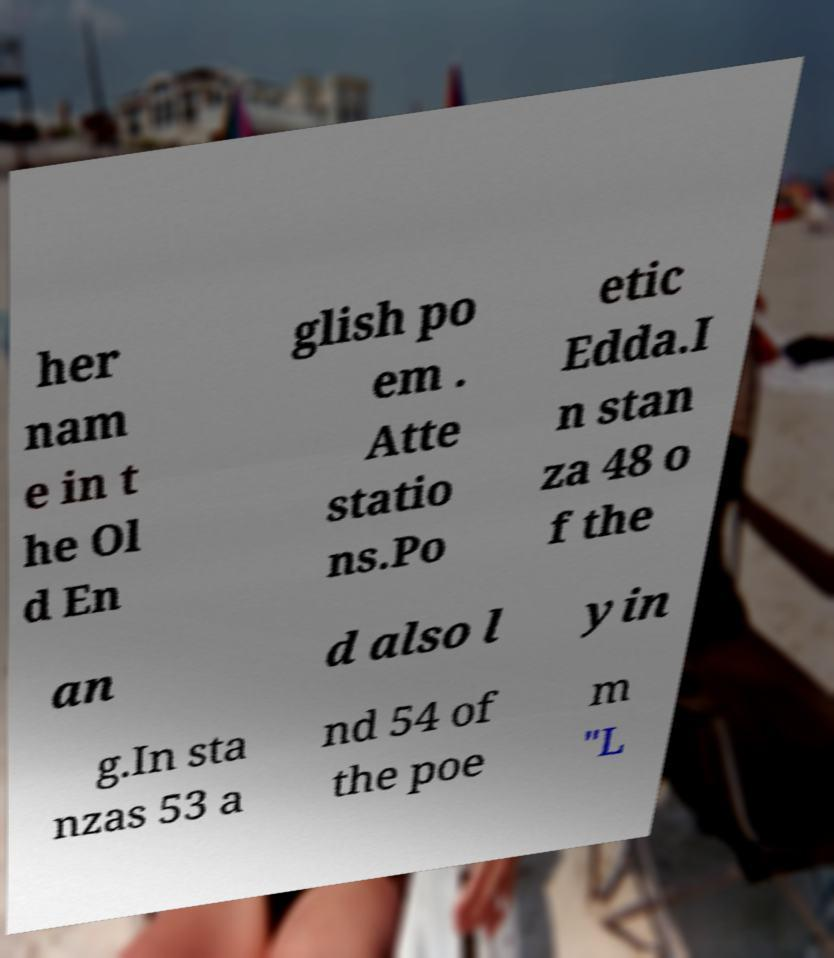Could you assist in decoding the text presented in this image and type it out clearly? her nam e in t he Ol d En glish po em . Atte statio ns.Po etic Edda.I n stan za 48 o f the an d also l yin g.In sta nzas 53 a nd 54 of the poe m "L 